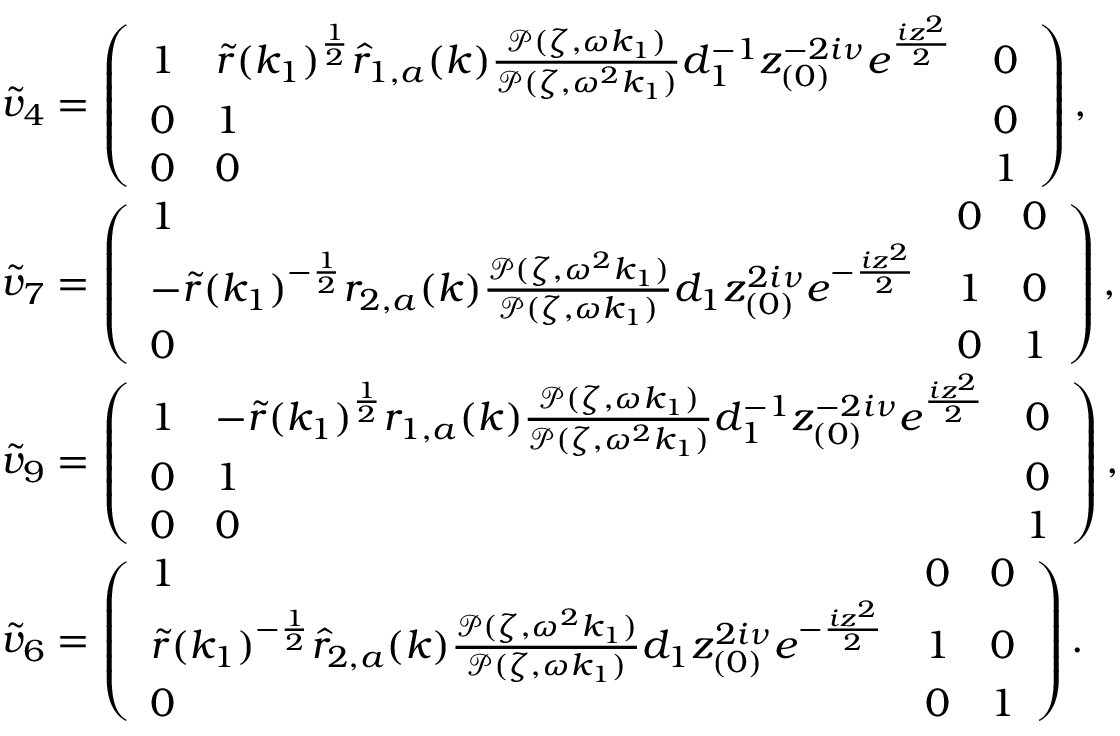<formula> <loc_0><loc_0><loc_500><loc_500>\begin{array} { r l } & { \tilde { v } _ { 4 } = \left ( \begin{array} { l l l } { 1 } & { \tilde { r } ( k _ { 1 } ) ^ { \frac { 1 } { 2 } } \hat { r } _ { 1 , a } ( k ) \frac { \mathcal { P } ( \zeta , \omega k _ { 1 } ) } { \mathcal { P } ( \zeta , \omega ^ { 2 } k _ { 1 } ) } d _ { 1 } ^ { - 1 } z _ { ( 0 ) } ^ { - 2 i \nu } e ^ { \frac { i z ^ { 2 } } { 2 } } } & { 0 } \\ { 0 } & { 1 } & { 0 } \\ { 0 } & { 0 } & { 1 } \end{array} \right ) , } \\ & { \tilde { v } _ { 7 } = \left ( \begin{array} { l l l } { 1 } & { 0 } & { 0 } \\ { - \tilde { r } ( k _ { 1 } ) ^ { - \frac { 1 } { 2 } } r _ { 2 , a } ( k ) \frac { \mathcal { P } ( \zeta , \omega ^ { 2 } k _ { 1 } ) } { \mathcal { P } ( \zeta , \omega k _ { 1 } ) } d _ { 1 } z _ { ( 0 ) } ^ { 2 i \nu } e ^ { - \frac { i z ^ { 2 } } { 2 } } } & { 1 } & { 0 } \\ { 0 } & { 0 } & { 1 } \end{array} \right ) , } \\ & { \tilde { v } _ { 9 } = \left ( \begin{array} { l l l } { 1 } & { - \tilde { r } ( k _ { 1 } ) ^ { \frac { 1 } { 2 } } r _ { 1 , a } ( k ) \frac { \mathcal { P } ( \zeta , \omega k _ { 1 } ) } { \mathcal { P } ( \zeta , \omega ^ { 2 } k _ { 1 } ) } d _ { 1 } ^ { - 1 } z _ { ( 0 ) } ^ { - 2 i \nu } e ^ { \frac { i z ^ { 2 } } { 2 } } } & { 0 } \\ { 0 } & { 1 } & { 0 } \\ { 0 } & { 0 } & { 1 } \end{array} \right ) , } \\ & { \tilde { v } _ { 6 } = \left ( \begin{array} { l l l } { 1 } & { 0 } & { 0 } \\ { \tilde { r } ( k _ { 1 } ) ^ { - \frac { 1 } { 2 } } \hat { r } _ { 2 , a } ( k ) \frac { \mathcal { P } ( \zeta , \omega ^ { 2 } k _ { 1 } ) } { \mathcal { P } ( \zeta , \omega k _ { 1 } ) } d _ { 1 } z _ { ( 0 ) } ^ { 2 i \nu } e ^ { - \frac { i z ^ { 2 } } { 2 } } } & { 1 } & { 0 } \\ { 0 } & { 0 } & { 1 } \end{array} \right ) . } \end{array}</formula> 